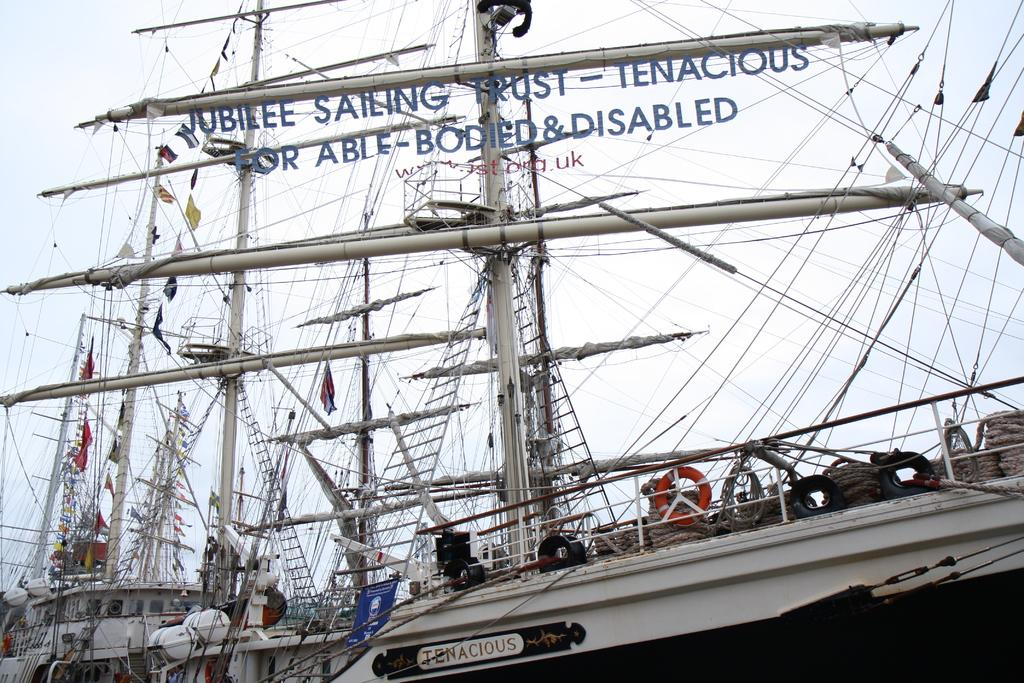What is located in the middle of the image? In the middle of the image, there are boats, tubes, cables, ropes, flags, and text. Can you describe the boats in the image? The boats are in the middle of the image, but their specific details are not mentioned in the facts. What other objects are present in the middle of the image? Besides the boats, there are tubes, cables, ropes, flags, and text in the middle of the image. What can be seen in the background of the image? The sky is visible in the background of the image. What type of treatment is being administered to the toe in the image? There is no toe or treatment present in the image. Can you tell me what the father is doing in the image? There is no mention of a father or any person's actions in the image. 